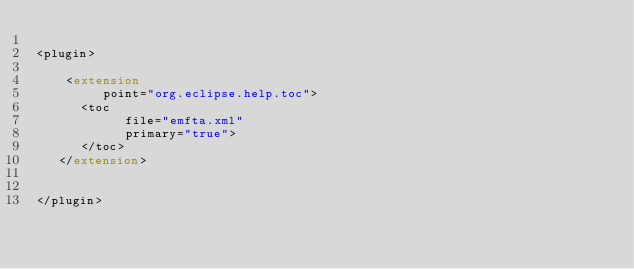<code> <loc_0><loc_0><loc_500><loc_500><_XML_>
<plugin>

    <extension
         point="org.eclipse.help.toc">
      <toc
            file="emfta.xml"
            primary="true">
      </toc>
   </extension>
   

</plugin>
</code> 